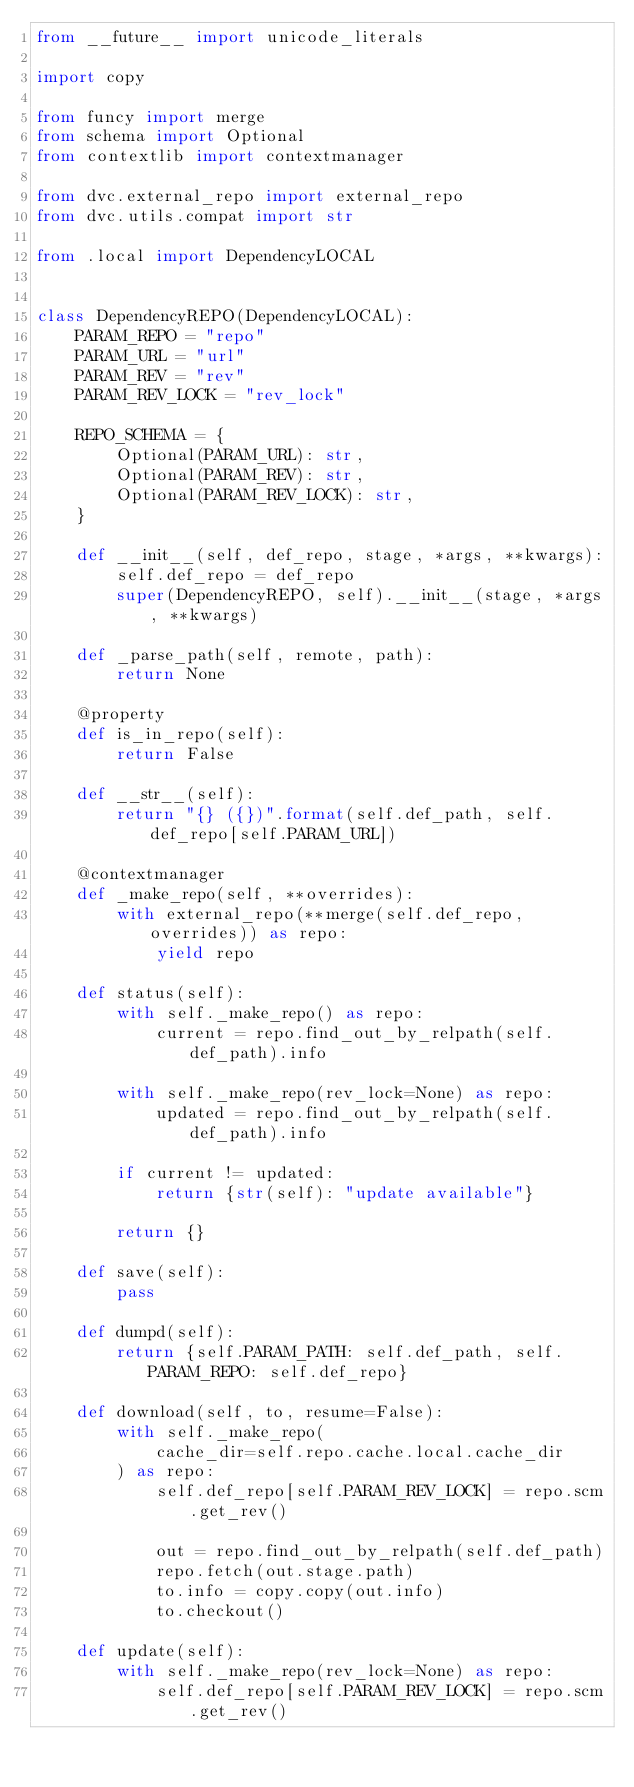Convert code to text. <code><loc_0><loc_0><loc_500><loc_500><_Python_>from __future__ import unicode_literals

import copy

from funcy import merge
from schema import Optional
from contextlib import contextmanager

from dvc.external_repo import external_repo
from dvc.utils.compat import str

from .local import DependencyLOCAL


class DependencyREPO(DependencyLOCAL):
    PARAM_REPO = "repo"
    PARAM_URL = "url"
    PARAM_REV = "rev"
    PARAM_REV_LOCK = "rev_lock"

    REPO_SCHEMA = {
        Optional(PARAM_URL): str,
        Optional(PARAM_REV): str,
        Optional(PARAM_REV_LOCK): str,
    }

    def __init__(self, def_repo, stage, *args, **kwargs):
        self.def_repo = def_repo
        super(DependencyREPO, self).__init__(stage, *args, **kwargs)

    def _parse_path(self, remote, path):
        return None

    @property
    def is_in_repo(self):
        return False

    def __str__(self):
        return "{} ({})".format(self.def_path, self.def_repo[self.PARAM_URL])

    @contextmanager
    def _make_repo(self, **overrides):
        with external_repo(**merge(self.def_repo, overrides)) as repo:
            yield repo

    def status(self):
        with self._make_repo() as repo:
            current = repo.find_out_by_relpath(self.def_path).info

        with self._make_repo(rev_lock=None) as repo:
            updated = repo.find_out_by_relpath(self.def_path).info

        if current != updated:
            return {str(self): "update available"}

        return {}

    def save(self):
        pass

    def dumpd(self):
        return {self.PARAM_PATH: self.def_path, self.PARAM_REPO: self.def_repo}

    def download(self, to, resume=False):
        with self._make_repo(
            cache_dir=self.repo.cache.local.cache_dir
        ) as repo:
            self.def_repo[self.PARAM_REV_LOCK] = repo.scm.get_rev()

            out = repo.find_out_by_relpath(self.def_path)
            repo.fetch(out.stage.path)
            to.info = copy.copy(out.info)
            to.checkout()

    def update(self):
        with self._make_repo(rev_lock=None) as repo:
            self.def_repo[self.PARAM_REV_LOCK] = repo.scm.get_rev()
</code> 